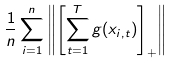<formula> <loc_0><loc_0><loc_500><loc_500>\frac { 1 } { n } \sum _ { i = 1 } ^ { n } \left \| \left [ \sum _ { t = 1 } ^ { T } g ( x _ { i , t } ) \right ] _ { + } \right \|</formula> 